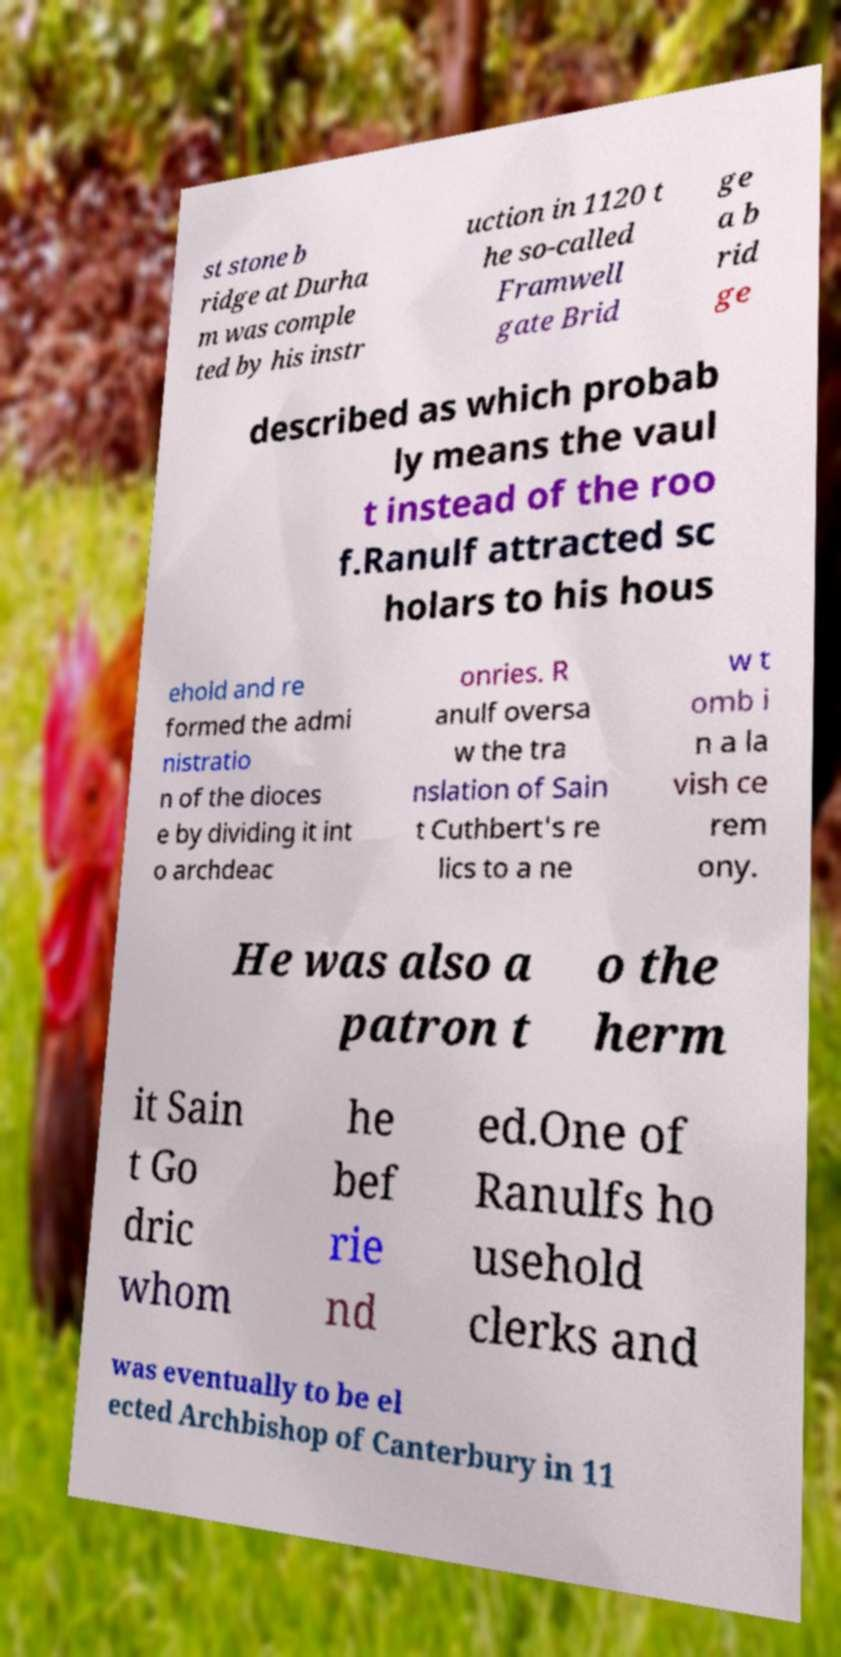For documentation purposes, I need the text within this image transcribed. Could you provide that? st stone b ridge at Durha m was comple ted by his instr uction in 1120 t he so-called Framwell gate Brid ge a b rid ge described as which probab ly means the vaul t instead of the roo f.Ranulf attracted sc holars to his hous ehold and re formed the admi nistratio n of the dioces e by dividing it int o archdeac onries. R anulf oversa w the tra nslation of Sain t Cuthbert's re lics to a ne w t omb i n a la vish ce rem ony. He was also a patron t o the herm it Sain t Go dric whom he bef rie nd ed.One of Ranulfs ho usehold clerks and was eventually to be el ected Archbishop of Canterbury in 11 